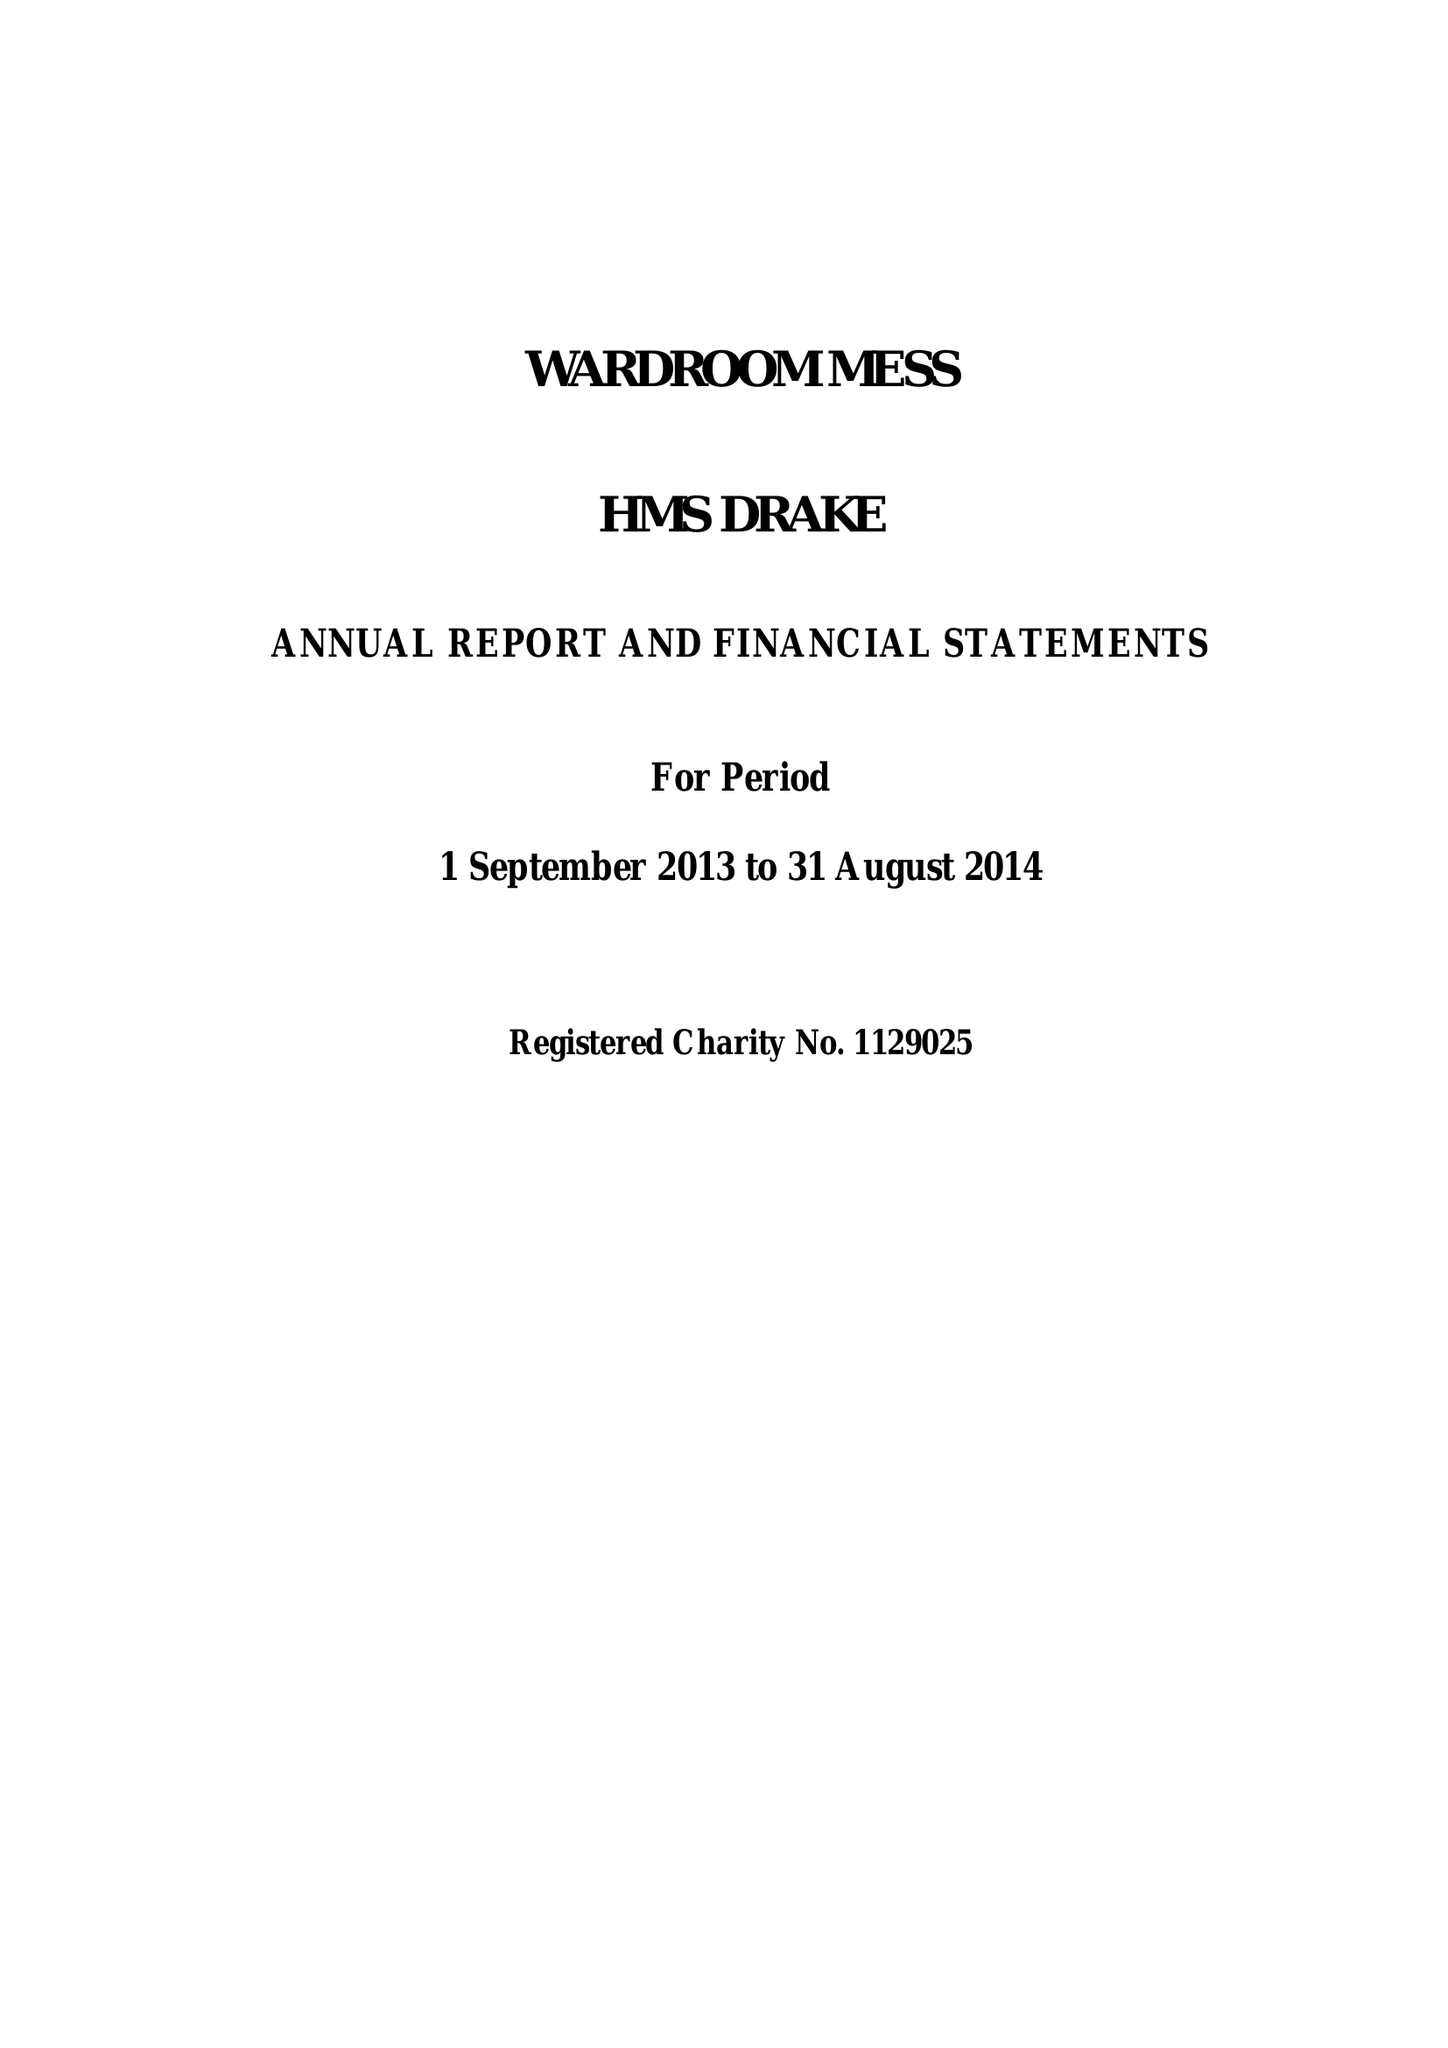What is the value for the charity_name?
Answer the question using a single word or phrase. The Wardroom Mess, Hms Drake 